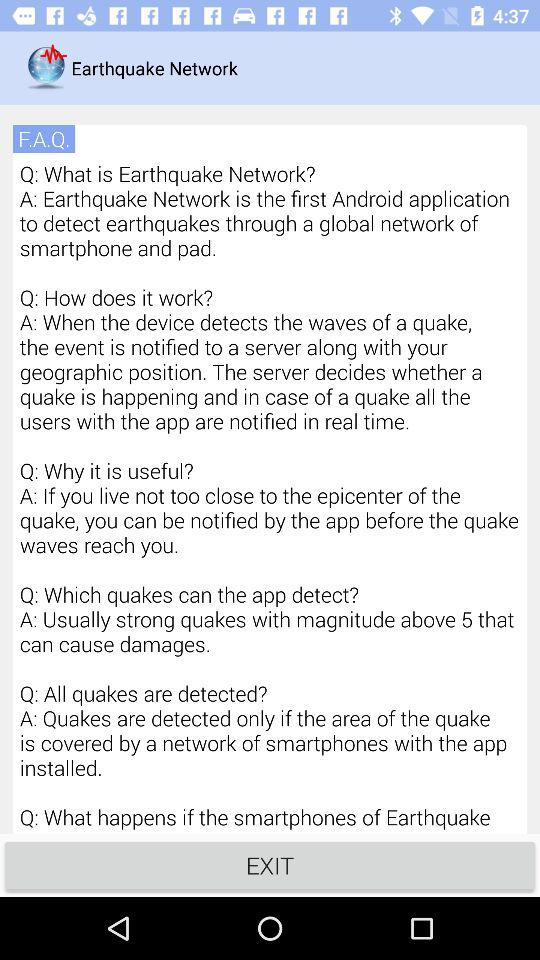How many questions are there in this FAQ?
Answer the question using a single word or phrase. 6 